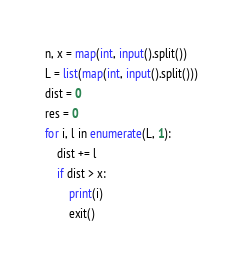Convert code to text. <code><loc_0><loc_0><loc_500><loc_500><_Python_>n, x = map(int, input().split())
L = list(map(int, input().split()))
dist = 0
res = 0
for i, l in enumerate(L, 1):
    dist += l
    if dist > x:
        print(i)
        exit()
</code> 